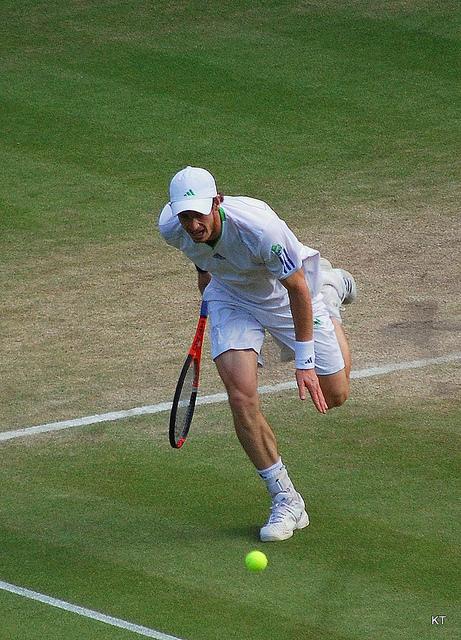Is he wearing all white?
Write a very short answer. Yes. What is the man wearing on his head?
Answer briefly. Hat. What is on this man's head?
Short answer required. Hat. Is the tennis ball traveling away from the man, or towards him?
Keep it brief. Towards. Is this man bending down to get a tennis ball?
Concise answer only. Yes. Where is the man playing?
Keep it brief. Tennis. 